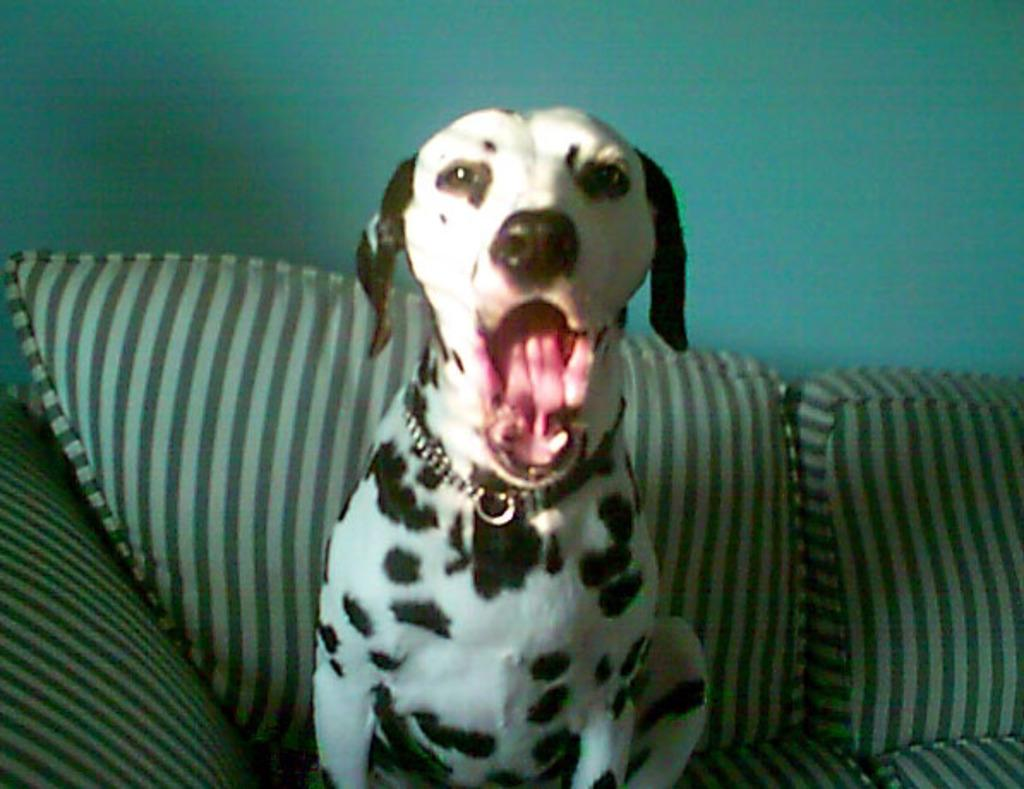What type of animal is in the image? There is a dog in the image. Where is the dog located? The dog is sitting on a sofa. What can be seen in the background of the image? There is a wall in the background of the image. What type of teeth can be seen in the image? There are no teeth visible in the image, as it features a dog sitting on a sofa and no teeth are mentioned in the facts provided. 